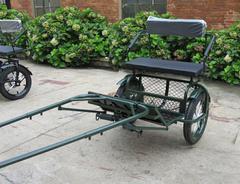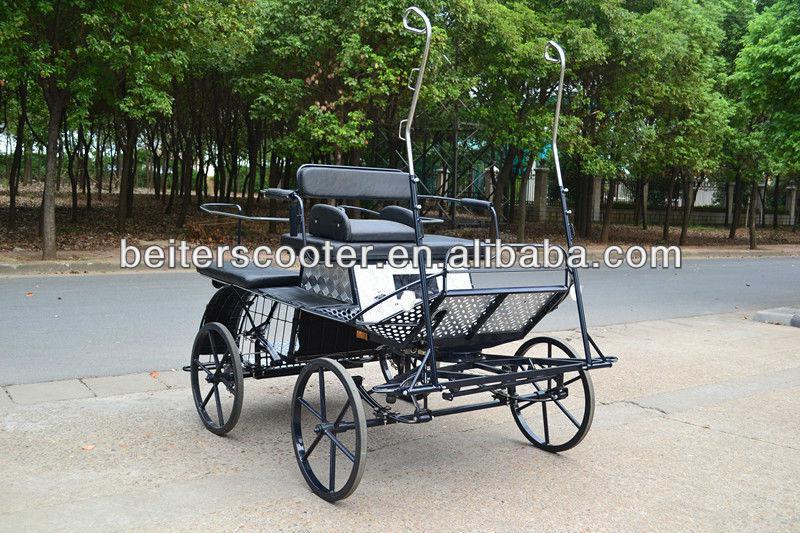The first image is the image on the left, the second image is the image on the right. Assess this claim about the two images: "The carriage is covered in the image on the right.". Correct or not? Answer yes or no. No. 